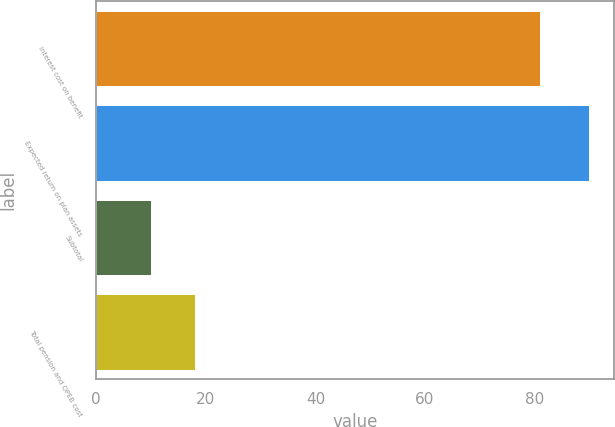Convert chart. <chart><loc_0><loc_0><loc_500><loc_500><bar_chart><fcel>Interest cost on benefit<fcel>Expected return on plan assets<fcel>Subtotal<fcel>Total pension and OPEB cost<nl><fcel>81<fcel>90<fcel>10<fcel>18<nl></chart> 